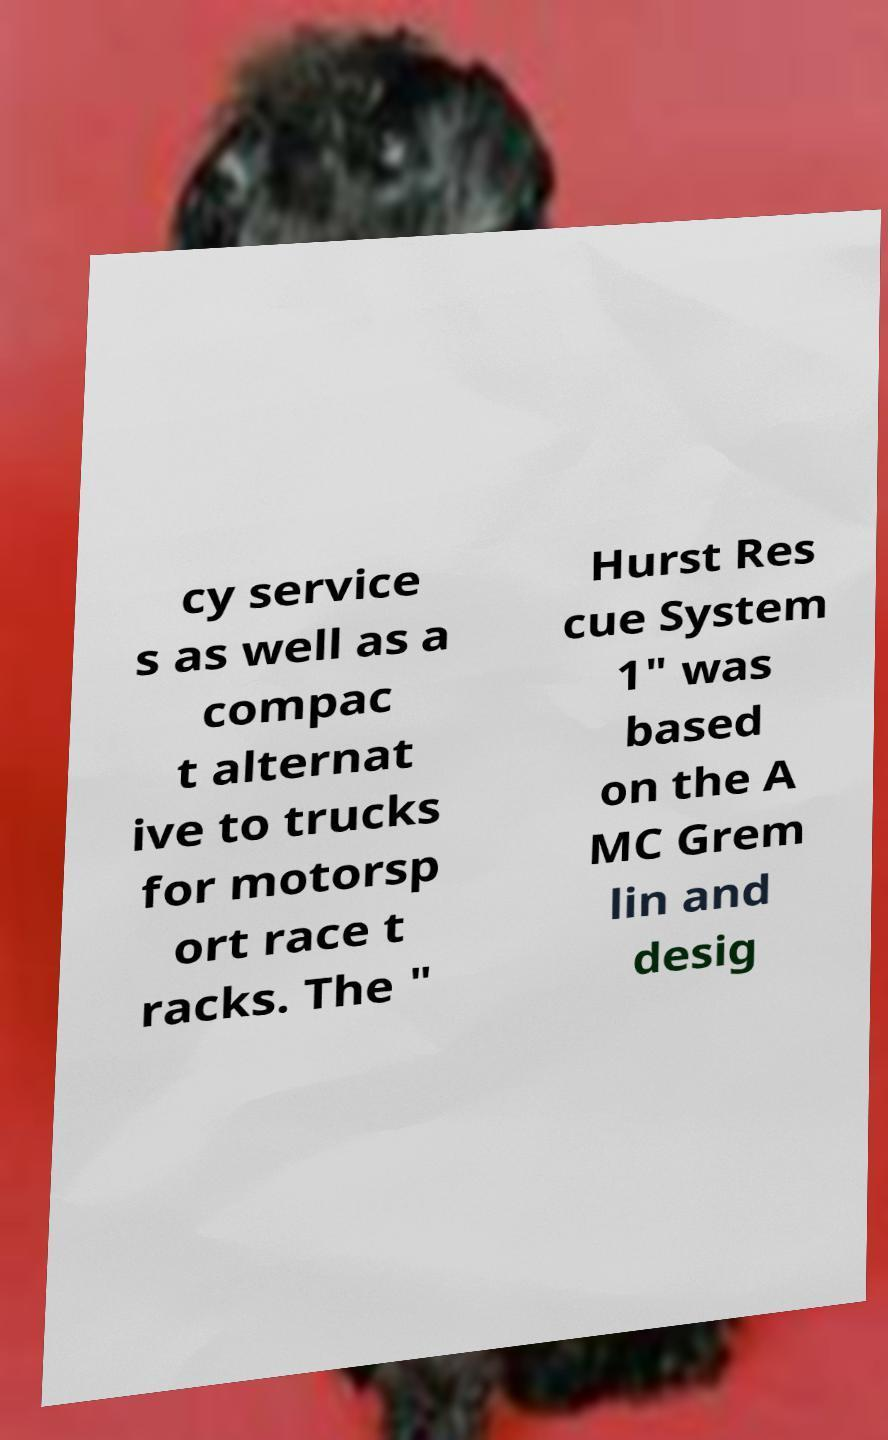Can you accurately transcribe the text from the provided image for me? cy service s as well as a compac t alternat ive to trucks for motorsp ort race t racks. The " Hurst Res cue System 1" was based on the A MC Grem lin and desig 